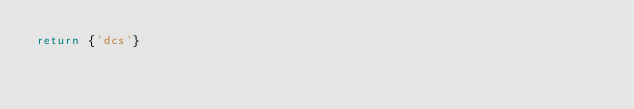Convert code to text. <code><loc_0><loc_0><loc_500><loc_500><_Lua_>return {'dcs'}</code> 